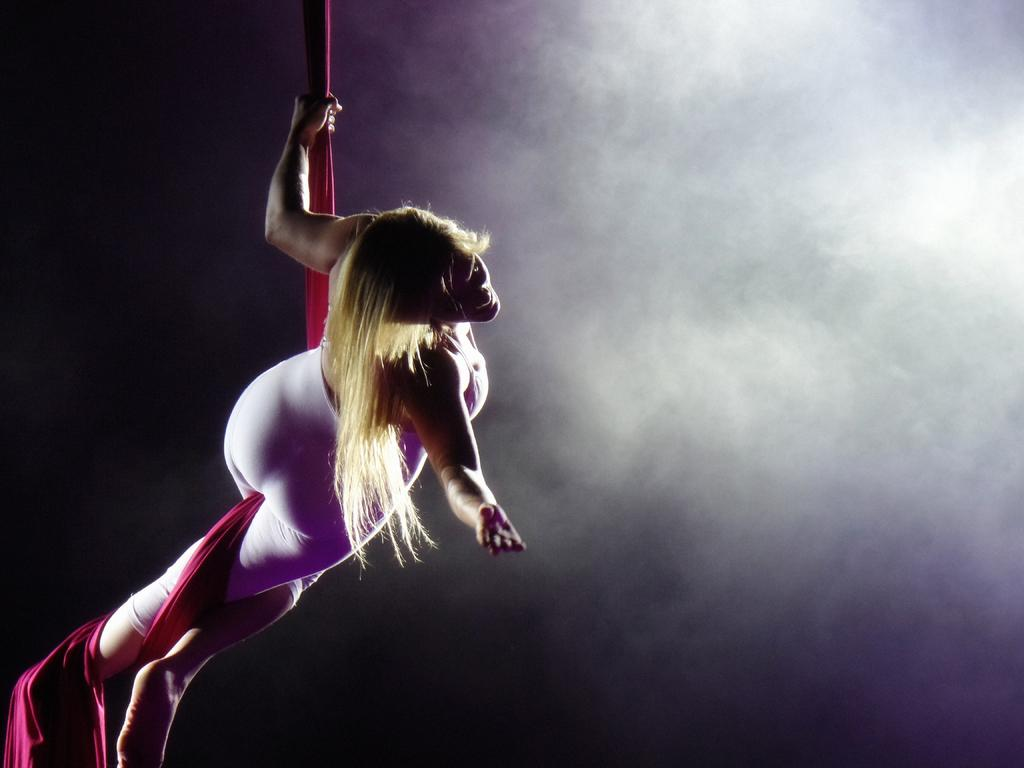Who is present in the image? There is a woman in the image. What is the woman holding in the image? The woman is holding a cloth. Can you describe the background of the image? The background of the image is blurry. How many cows can be seen grazing in the background of the image? There are no cows visible in the image; the background is blurry. What type of letters are being written by the woman in the image? There are no letters being written by the woman in the image; she is holding a cloth. 